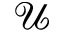Convert formula to latex. <formula><loc_0><loc_0><loc_500><loc_500>\mathcal { U }</formula> 